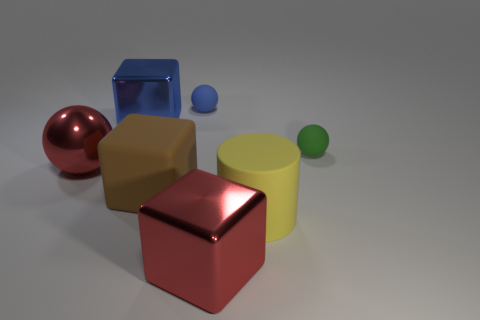There is a big shiny thing that is the same color as the large sphere; what is its shape?
Your answer should be compact. Cube. There is a large metallic cube that is left of the large red cube; is it the same color as the small ball that is to the left of the big red metal cube?
Make the answer very short. Yes. There is a big ball; is it the same color as the large metallic block in front of the tiny green matte sphere?
Your response must be concise. Yes. There is a ball that is the same material as the green object; what is its color?
Offer a terse response. Blue. How many big brown cubes are the same material as the tiny green thing?
Give a very brief answer. 1. How many rubber cubes are behind the tiny blue matte sphere?
Ensure brevity in your answer.  0. Are the tiny blue sphere on the right side of the large blue cube and the small sphere that is in front of the big blue metal object made of the same material?
Your answer should be compact. Yes. Is the number of small matte spheres on the left side of the large brown cube greater than the number of large metallic cubes that are to the left of the tiny green rubber object?
Offer a very short reply. No. There is a large cube that is the same color as the large ball; what material is it?
Offer a very short reply. Metal. Is there anything else that has the same shape as the yellow matte thing?
Keep it short and to the point. No. 